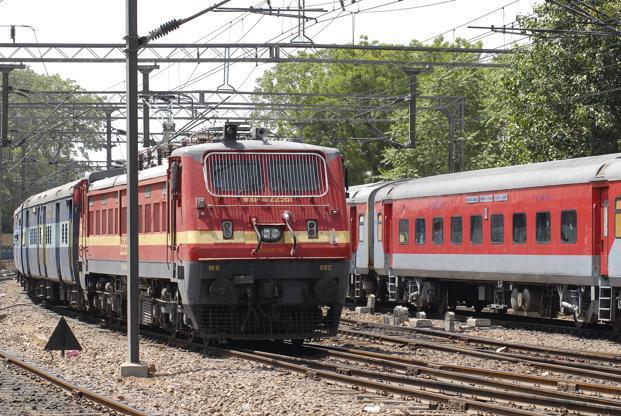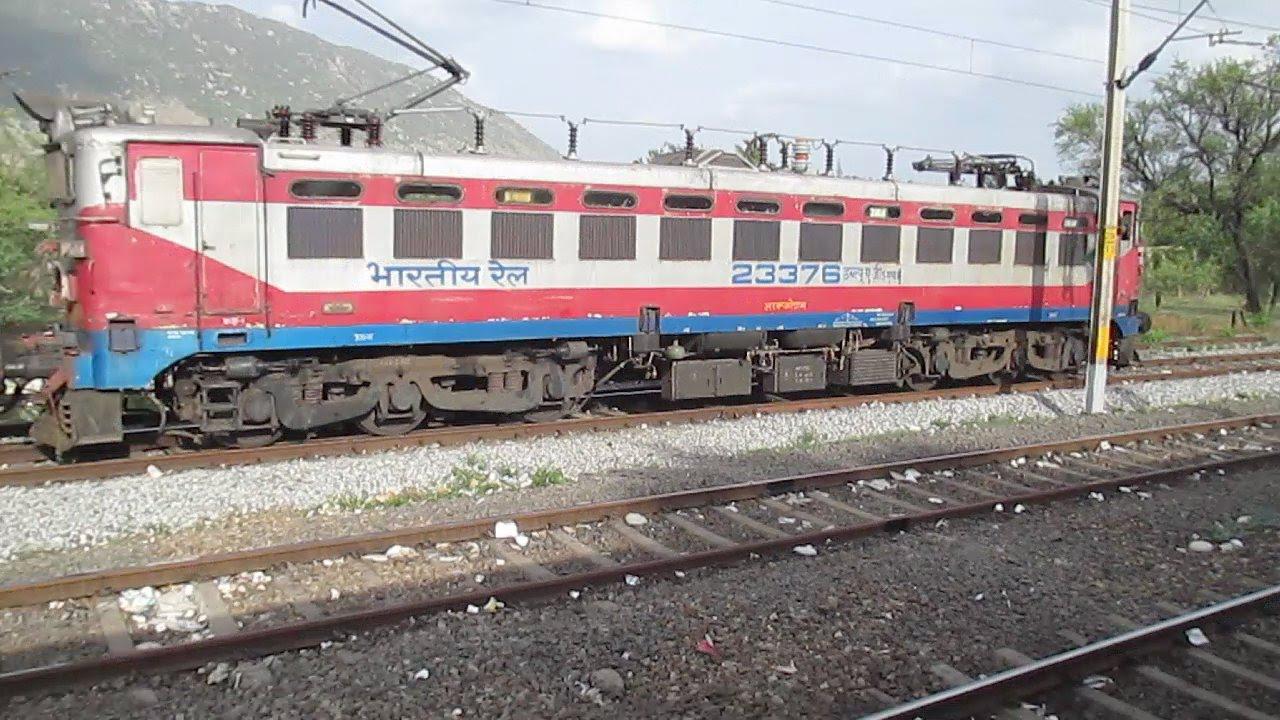The first image is the image on the left, the second image is the image on the right. Assess this claim about the two images: "An image shows a train with stripes of blue on the bottom, followed by red, white, red, and white on top.". Correct or not? Answer yes or no. Yes. The first image is the image on the left, the second image is the image on the right. For the images displayed, is the sentence "Each of the images shows a train pointed in the same direction." factually correct? Answer yes or no. No. 